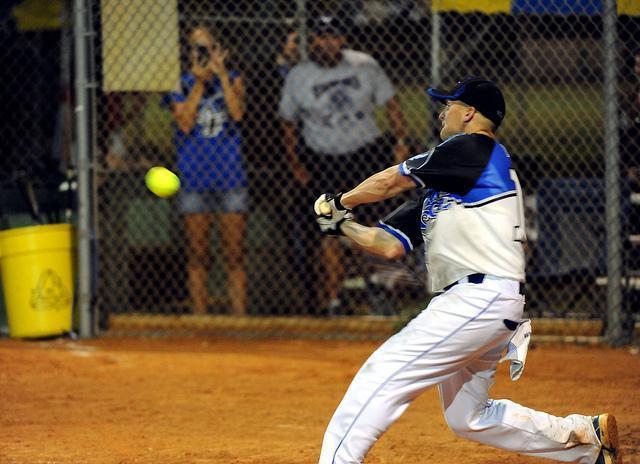How many people can you see?
Give a very brief answer. 3. 